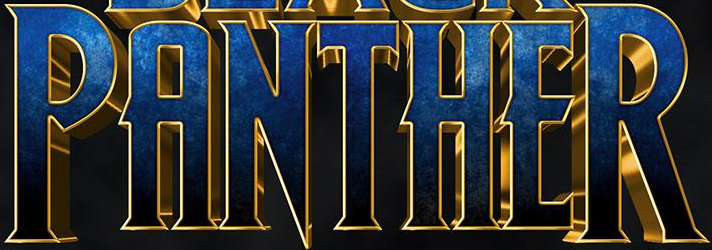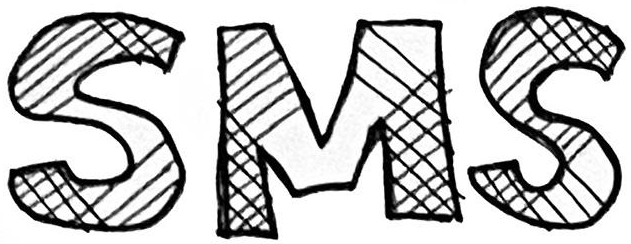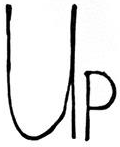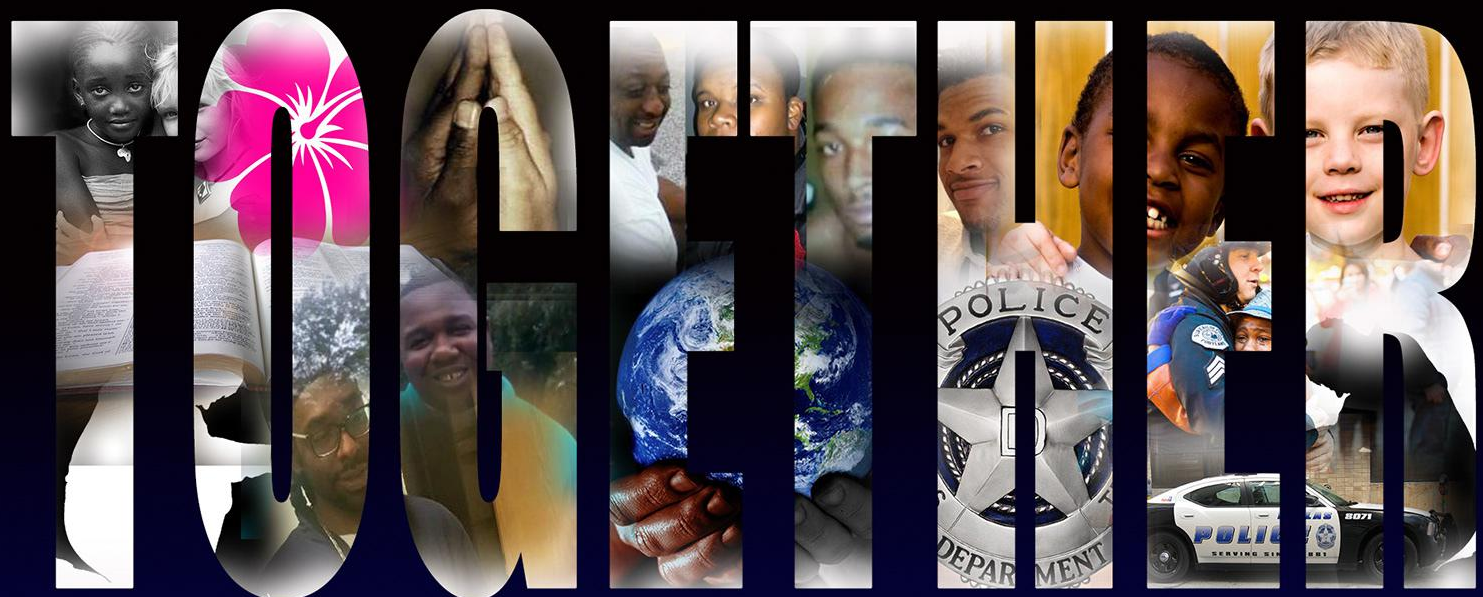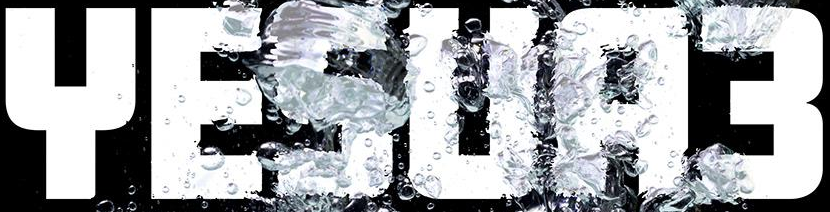What text appears in these images from left to right, separated by a semicolon? PANTHER; SMS; UP; TOGETHER; YESUA3 